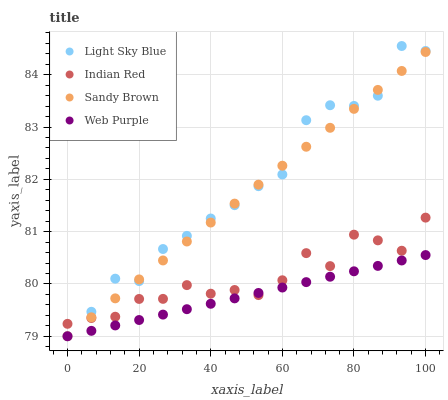Does Web Purple have the minimum area under the curve?
Answer yes or no. Yes. Does Light Sky Blue have the maximum area under the curve?
Answer yes or no. Yes. Does Sandy Brown have the minimum area under the curve?
Answer yes or no. No. Does Sandy Brown have the maximum area under the curve?
Answer yes or no. No. Is Web Purple the smoothest?
Answer yes or no. Yes. Is Light Sky Blue the roughest?
Answer yes or no. Yes. Is Sandy Brown the smoothest?
Answer yes or no. No. Is Sandy Brown the roughest?
Answer yes or no. No. Does Web Purple have the lowest value?
Answer yes or no. Yes. Does Indian Red have the lowest value?
Answer yes or no. No. Does Light Sky Blue have the highest value?
Answer yes or no. Yes. Does Sandy Brown have the highest value?
Answer yes or no. No. Does Web Purple intersect Light Sky Blue?
Answer yes or no. Yes. Is Web Purple less than Light Sky Blue?
Answer yes or no. No. Is Web Purple greater than Light Sky Blue?
Answer yes or no. No. 